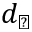<formula> <loc_0><loc_0><loc_500><loc_500>d _ { \perp }</formula> 